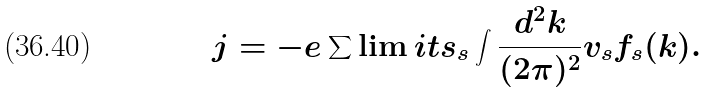Convert formula to latex. <formula><loc_0><loc_0><loc_500><loc_500>j = - e \sum \lim i t s _ { s } \int \frac { d ^ { 2 } k } { ( 2 \pi ) ^ { 2 } } v _ { s } f _ { s } ( k ) .</formula> 